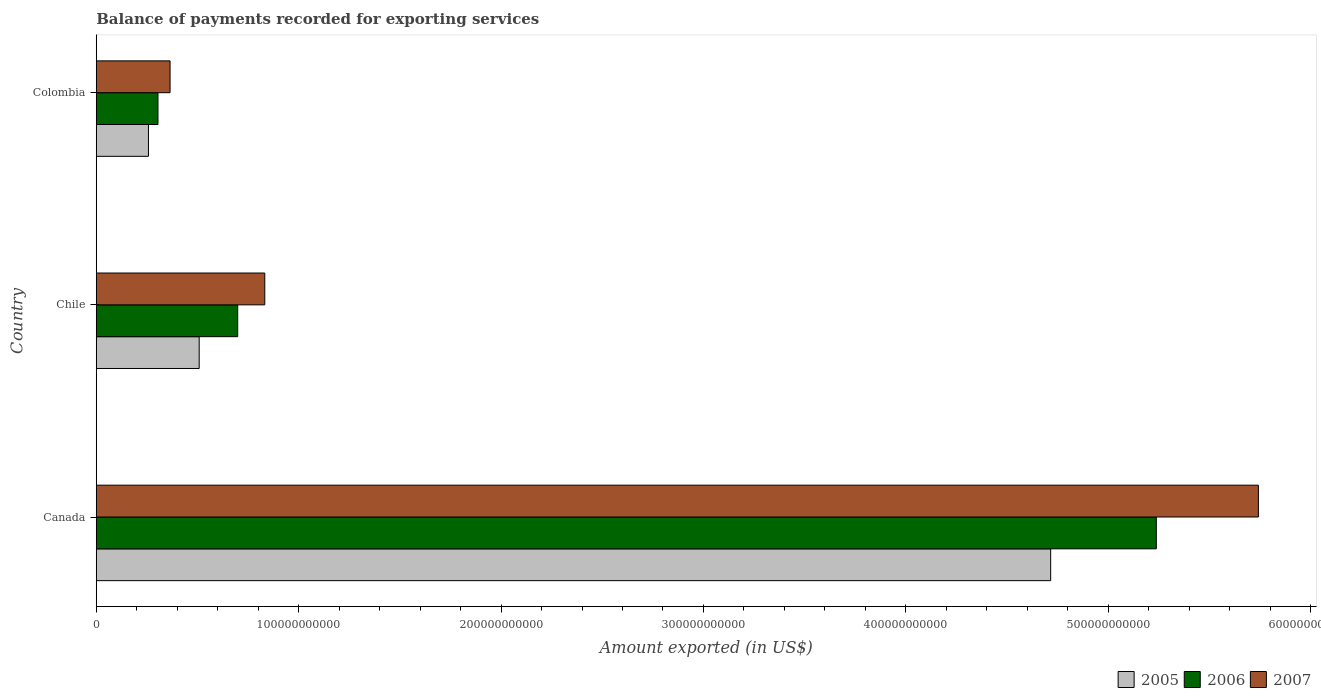How many groups of bars are there?
Offer a very short reply. 3. How many bars are there on the 1st tick from the top?
Your answer should be compact. 3. How many bars are there on the 1st tick from the bottom?
Your response must be concise. 3. What is the label of the 3rd group of bars from the top?
Your answer should be very brief. Canada. In how many cases, is the number of bars for a given country not equal to the number of legend labels?
Your answer should be very brief. 0. What is the amount exported in 2007 in Colombia?
Ensure brevity in your answer.  3.65e+1. Across all countries, what is the maximum amount exported in 2006?
Offer a very short reply. 5.24e+11. Across all countries, what is the minimum amount exported in 2005?
Your response must be concise. 2.58e+1. In which country was the amount exported in 2006 maximum?
Keep it short and to the point. Canada. What is the total amount exported in 2005 in the graph?
Your response must be concise. 5.48e+11. What is the difference between the amount exported in 2005 in Chile and that in Colombia?
Give a very brief answer. 2.51e+1. What is the difference between the amount exported in 2005 in Canada and the amount exported in 2006 in Colombia?
Give a very brief answer. 4.41e+11. What is the average amount exported in 2005 per country?
Provide a short and direct response. 1.83e+11. What is the difference between the amount exported in 2006 and amount exported in 2005 in Colombia?
Provide a short and direct response. 4.70e+09. In how many countries, is the amount exported in 2007 greater than 480000000000 US$?
Provide a succinct answer. 1. What is the ratio of the amount exported in 2005 in Canada to that in Colombia?
Make the answer very short. 18.29. What is the difference between the highest and the second highest amount exported in 2005?
Make the answer very short. 4.21e+11. What is the difference between the highest and the lowest amount exported in 2006?
Give a very brief answer. 4.93e+11. What does the 1st bar from the bottom in Colombia represents?
Provide a succinct answer. 2005. Is it the case that in every country, the sum of the amount exported in 2005 and amount exported in 2006 is greater than the amount exported in 2007?
Your answer should be very brief. Yes. Are all the bars in the graph horizontal?
Your answer should be very brief. Yes. What is the difference between two consecutive major ticks on the X-axis?
Your response must be concise. 1.00e+11. Does the graph contain any zero values?
Offer a very short reply. No. Does the graph contain grids?
Keep it short and to the point. No. What is the title of the graph?
Your response must be concise. Balance of payments recorded for exporting services. What is the label or title of the X-axis?
Your response must be concise. Amount exported (in US$). What is the label or title of the Y-axis?
Keep it short and to the point. Country. What is the Amount exported (in US$) in 2005 in Canada?
Provide a succinct answer. 4.72e+11. What is the Amount exported (in US$) of 2006 in Canada?
Provide a short and direct response. 5.24e+11. What is the Amount exported (in US$) in 2007 in Canada?
Keep it short and to the point. 5.74e+11. What is the Amount exported (in US$) in 2005 in Chile?
Give a very brief answer. 5.09e+1. What is the Amount exported (in US$) in 2006 in Chile?
Provide a short and direct response. 6.99e+1. What is the Amount exported (in US$) of 2007 in Chile?
Make the answer very short. 8.33e+1. What is the Amount exported (in US$) of 2005 in Colombia?
Keep it short and to the point. 2.58e+1. What is the Amount exported (in US$) in 2006 in Colombia?
Ensure brevity in your answer.  3.05e+1. What is the Amount exported (in US$) of 2007 in Colombia?
Make the answer very short. 3.65e+1. Across all countries, what is the maximum Amount exported (in US$) in 2005?
Your answer should be very brief. 4.72e+11. Across all countries, what is the maximum Amount exported (in US$) of 2006?
Give a very brief answer. 5.24e+11. Across all countries, what is the maximum Amount exported (in US$) of 2007?
Make the answer very short. 5.74e+11. Across all countries, what is the minimum Amount exported (in US$) of 2005?
Your response must be concise. 2.58e+1. Across all countries, what is the minimum Amount exported (in US$) of 2006?
Offer a very short reply. 3.05e+1. Across all countries, what is the minimum Amount exported (in US$) of 2007?
Give a very brief answer. 3.65e+1. What is the total Amount exported (in US$) in 2005 in the graph?
Ensure brevity in your answer.  5.48e+11. What is the total Amount exported (in US$) in 2006 in the graph?
Offer a very short reply. 6.24e+11. What is the total Amount exported (in US$) in 2007 in the graph?
Offer a terse response. 6.94e+11. What is the difference between the Amount exported (in US$) in 2005 in Canada and that in Chile?
Offer a terse response. 4.21e+11. What is the difference between the Amount exported (in US$) in 2006 in Canada and that in Chile?
Offer a terse response. 4.54e+11. What is the difference between the Amount exported (in US$) of 2007 in Canada and that in Chile?
Make the answer very short. 4.91e+11. What is the difference between the Amount exported (in US$) of 2005 in Canada and that in Colombia?
Give a very brief answer. 4.46e+11. What is the difference between the Amount exported (in US$) in 2006 in Canada and that in Colombia?
Your response must be concise. 4.93e+11. What is the difference between the Amount exported (in US$) of 2007 in Canada and that in Colombia?
Ensure brevity in your answer.  5.38e+11. What is the difference between the Amount exported (in US$) of 2005 in Chile and that in Colombia?
Give a very brief answer. 2.51e+1. What is the difference between the Amount exported (in US$) in 2006 in Chile and that in Colombia?
Give a very brief answer. 3.94e+1. What is the difference between the Amount exported (in US$) in 2007 in Chile and that in Colombia?
Your response must be concise. 4.68e+1. What is the difference between the Amount exported (in US$) in 2005 in Canada and the Amount exported (in US$) in 2006 in Chile?
Your response must be concise. 4.02e+11. What is the difference between the Amount exported (in US$) in 2005 in Canada and the Amount exported (in US$) in 2007 in Chile?
Provide a short and direct response. 3.88e+11. What is the difference between the Amount exported (in US$) in 2006 in Canada and the Amount exported (in US$) in 2007 in Chile?
Your answer should be very brief. 4.40e+11. What is the difference between the Amount exported (in US$) in 2005 in Canada and the Amount exported (in US$) in 2006 in Colombia?
Your answer should be compact. 4.41e+11. What is the difference between the Amount exported (in US$) of 2005 in Canada and the Amount exported (in US$) of 2007 in Colombia?
Give a very brief answer. 4.35e+11. What is the difference between the Amount exported (in US$) of 2006 in Canada and the Amount exported (in US$) of 2007 in Colombia?
Your answer should be very brief. 4.87e+11. What is the difference between the Amount exported (in US$) in 2005 in Chile and the Amount exported (in US$) in 2006 in Colombia?
Provide a succinct answer. 2.04e+1. What is the difference between the Amount exported (in US$) of 2005 in Chile and the Amount exported (in US$) of 2007 in Colombia?
Ensure brevity in your answer.  1.44e+1. What is the difference between the Amount exported (in US$) of 2006 in Chile and the Amount exported (in US$) of 2007 in Colombia?
Ensure brevity in your answer.  3.34e+1. What is the average Amount exported (in US$) of 2005 per country?
Offer a very short reply. 1.83e+11. What is the average Amount exported (in US$) in 2006 per country?
Ensure brevity in your answer.  2.08e+11. What is the average Amount exported (in US$) in 2007 per country?
Make the answer very short. 2.31e+11. What is the difference between the Amount exported (in US$) of 2005 and Amount exported (in US$) of 2006 in Canada?
Provide a succinct answer. -5.22e+1. What is the difference between the Amount exported (in US$) in 2005 and Amount exported (in US$) in 2007 in Canada?
Ensure brevity in your answer.  -1.03e+11. What is the difference between the Amount exported (in US$) of 2006 and Amount exported (in US$) of 2007 in Canada?
Offer a very short reply. -5.04e+1. What is the difference between the Amount exported (in US$) in 2005 and Amount exported (in US$) in 2006 in Chile?
Offer a terse response. -1.90e+1. What is the difference between the Amount exported (in US$) of 2005 and Amount exported (in US$) of 2007 in Chile?
Offer a very short reply. -3.24e+1. What is the difference between the Amount exported (in US$) in 2006 and Amount exported (in US$) in 2007 in Chile?
Your response must be concise. -1.34e+1. What is the difference between the Amount exported (in US$) of 2005 and Amount exported (in US$) of 2006 in Colombia?
Provide a short and direct response. -4.70e+09. What is the difference between the Amount exported (in US$) in 2005 and Amount exported (in US$) in 2007 in Colombia?
Provide a succinct answer. -1.07e+1. What is the difference between the Amount exported (in US$) of 2006 and Amount exported (in US$) of 2007 in Colombia?
Ensure brevity in your answer.  -5.97e+09. What is the ratio of the Amount exported (in US$) in 2005 in Canada to that in Chile?
Ensure brevity in your answer.  9.27. What is the ratio of the Amount exported (in US$) in 2006 in Canada to that in Chile?
Give a very brief answer. 7.49. What is the ratio of the Amount exported (in US$) in 2007 in Canada to that in Chile?
Ensure brevity in your answer.  6.9. What is the ratio of the Amount exported (in US$) in 2005 in Canada to that in Colombia?
Give a very brief answer. 18.29. What is the ratio of the Amount exported (in US$) of 2006 in Canada to that in Colombia?
Your response must be concise. 17.18. What is the ratio of the Amount exported (in US$) of 2007 in Canada to that in Colombia?
Your response must be concise. 15.75. What is the ratio of the Amount exported (in US$) in 2005 in Chile to that in Colombia?
Provide a short and direct response. 1.97. What is the ratio of the Amount exported (in US$) of 2006 in Chile to that in Colombia?
Provide a succinct answer. 2.29. What is the ratio of the Amount exported (in US$) of 2007 in Chile to that in Colombia?
Your answer should be very brief. 2.28. What is the difference between the highest and the second highest Amount exported (in US$) in 2005?
Offer a very short reply. 4.21e+11. What is the difference between the highest and the second highest Amount exported (in US$) in 2006?
Provide a succinct answer. 4.54e+11. What is the difference between the highest and the second highest Amount exported (in US$) in 2007?
Provide a short and direct response. 4.91e+11. What is the difference between the highest and the lowest Amount exported (in US$) of 2005?
Provide a short and direct response. 4.46e+11. What is the difference between the highest and the lowest Amount exported (in US$) in 2006?
Give a very brief answer. 4.93e+11. What is the difference between the highest and the lowest Amount exported (in US$) in 2007?
Provide a short and direct response. 5.38e+11. 